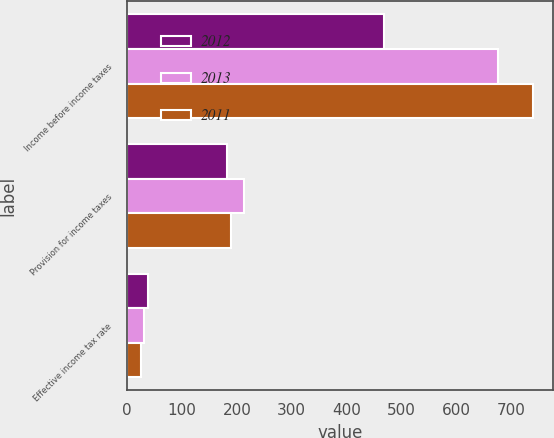Convert chart. <chart><loc_0><loc_0><loc_500><loc_500><stacked_bar_chart><ecel><fcel>Income before income taxes<fcel>Provision for income taxes<fcel>Effective income tax rate<nl><fcel>2012<fcel>468<fcel>181.2<fcel>38.7<nl><fcel>2013<fcel>674.8<fcel>213.3<fcel>31.6<nl><fcel>2011<fcel>738.4<fcel>190.2<fcel>25.8<nl></chart> 